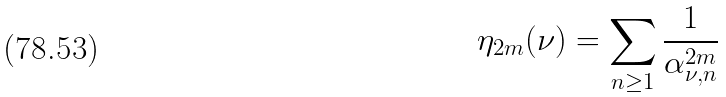Convert formula to latex. <formula><loc_0><loc_0><loc_500><loc_500>\eta _ { 2 m } ( \nu ) = \sum _ { n \geq 1 } \frac { 1 } { \alpha ^ { 2 m } _ { \nu , n } }</formula> 